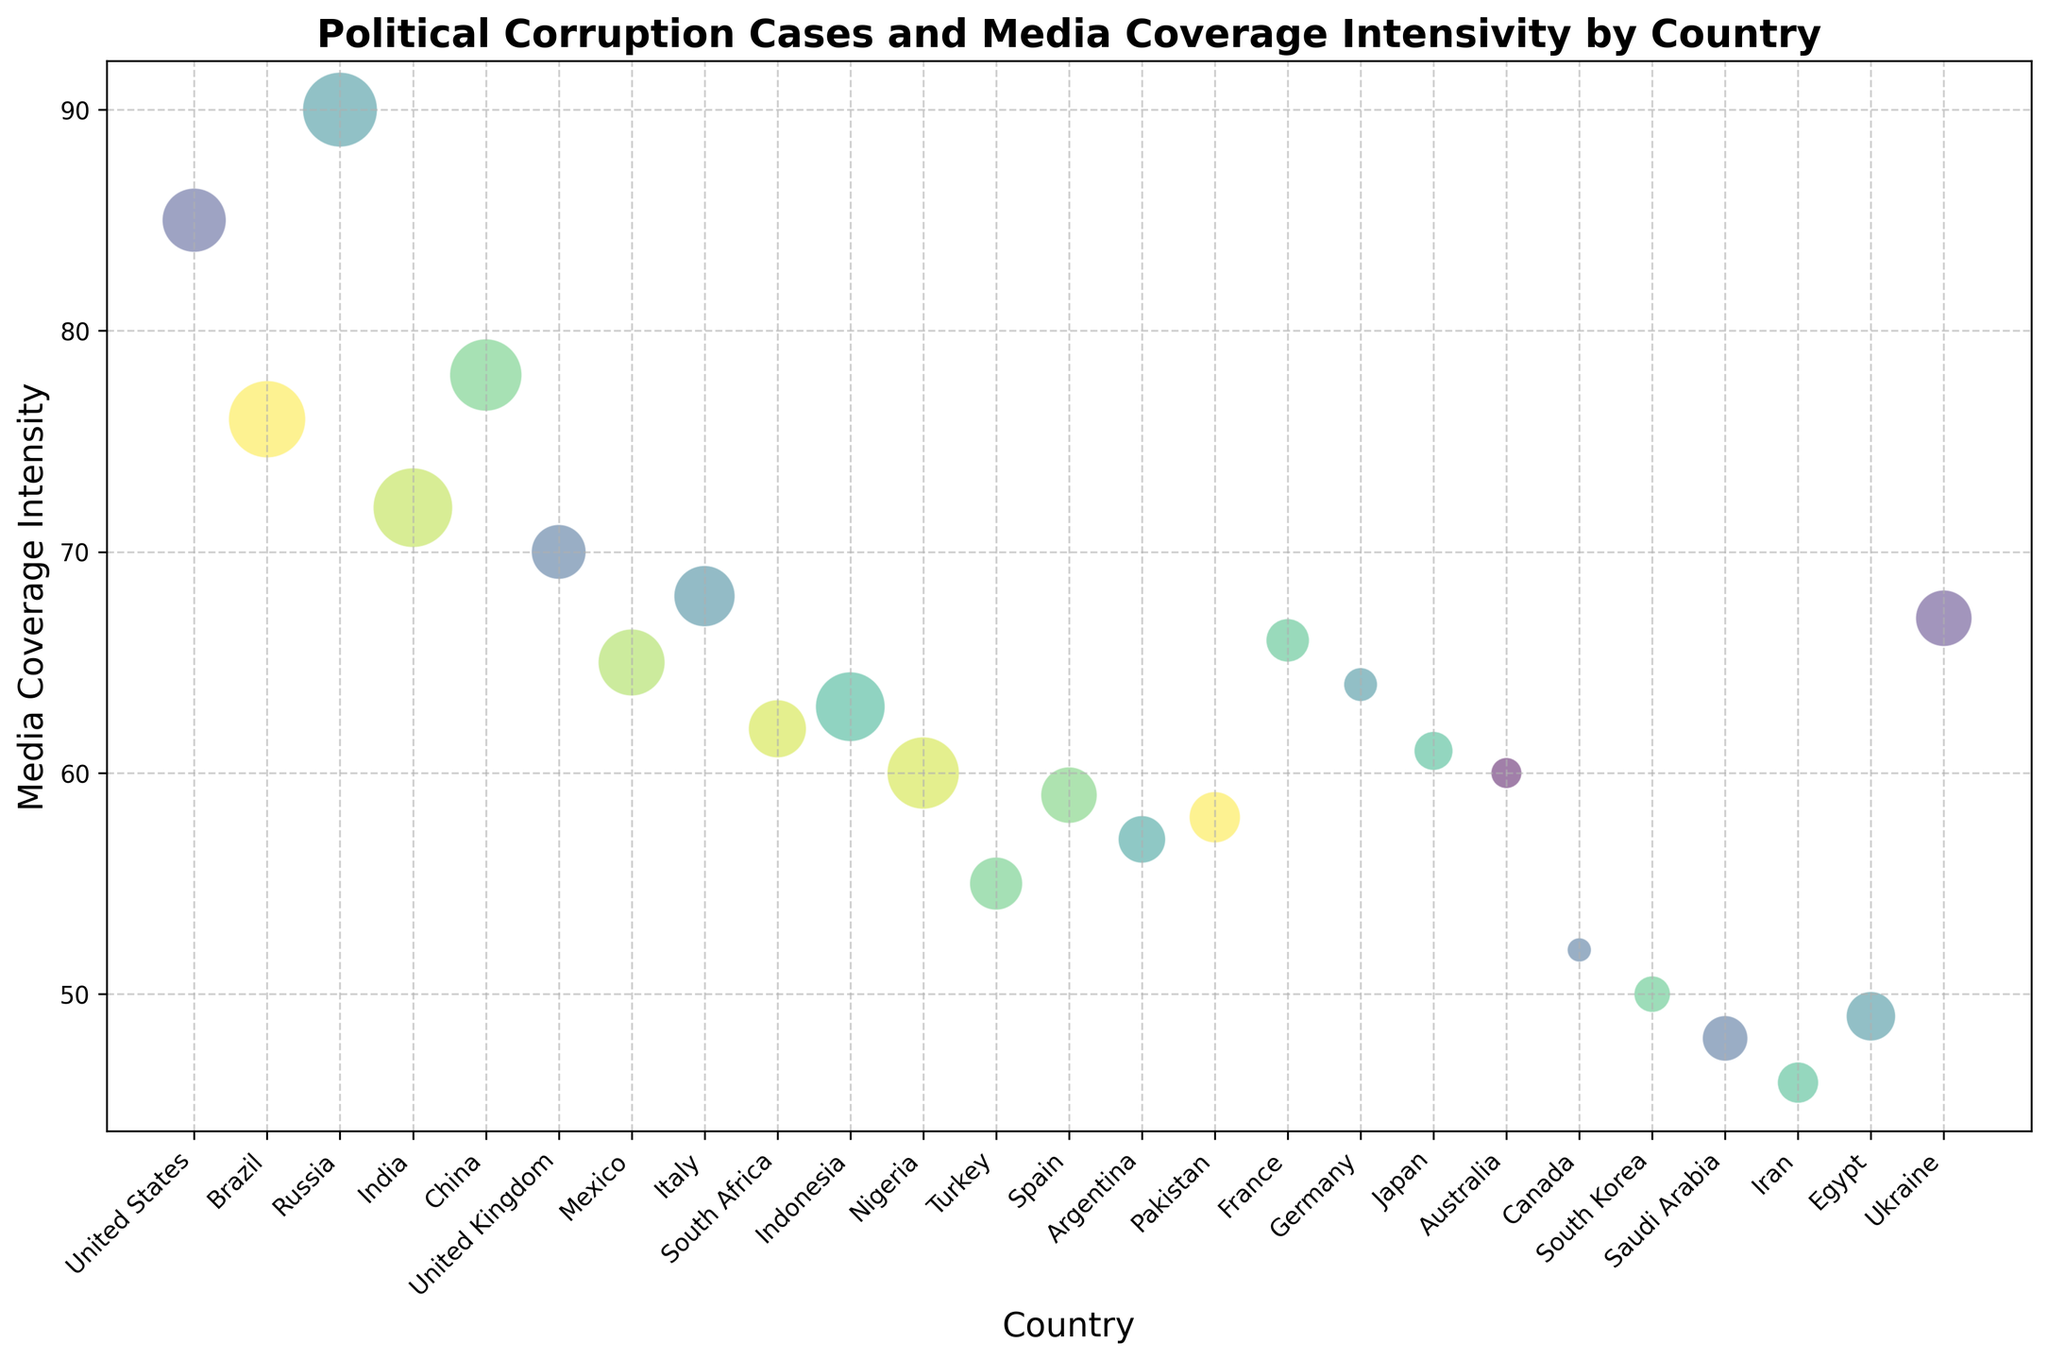Which country has the highest media coverage intensity for political corruption cases? Check the y-axis for the country with the highest value. Russia has the highest media coverage intensity at 90.
Answer: Russia Which country has the lowest number of corruption cases? Compare the bubble sizes to find the smallest one. Canada has the smallest bubble, indicating it has the fewest corruption cases, which is 55.
Answer: Canada Compare the corruption cases and media coverage intensity between the United States and Russia. The United States has 150 corruption cases and a media coverage intensity of 85. Russia has 190 corruption cases and a media coverage intensity of 90. Russia has more corruption cases and higher media coverage intensity compared to the United States.
Answer: Russia has more cases and higher intensity What is the difference in media coverage intensity between India and the United Kingdom? India has a media coverage intensity of 72, and the United Kingdom has 70. The difference is 72 - 70 = 2.
Answer: 2 Which country has the most corruption cases, and what is its media coverage intensity? Check the bubble sizes to find the largest one. India has the most corruption cases at 210. Its media coverage intensity is 72.
Answer: India, 72 Find the average media coverage intensity of the countries with over 150 corruption cases. Countries with over 150 corruption cases are the United States, Brazil, Russia, India, China, and Mexico. Their media coverage intensities are 85, 76, 90, 72, 78, and 65. Average = (85 + 76 + 90 + 72 + 78 + 65) / 6 = 77.67.
Answer: 77.67 What is the combined total corruption cases of Nigeria and Egypt, and which has higher media coverage intensity? Nigeria has 180 corruption cases and Egypt has 105. Combined total = 180 + 105 = 285. Comparing media coverage intensity, Nigeria has 60 and Egypt has 49; thus, Nigeria's is higher.
Answer: 285, Nigeria How does the media coverage intensity of France compare with that of Spain? France has a media coverage intensity of 66, and Spain has 59. France has a higher media coverage intensity than Spain.
Answer: France has higher intensity Which country has a similar number of corruption cases to China but a higher media coverage intensity? China has 180 corruption cases. Nigeria also has 180 corruption cases but has a lower media coverage intensity (60 vs. 78). Therefore, Russia has a similar number of cases (190) and a higher media coverage intensity (90).
Answer: Russia 